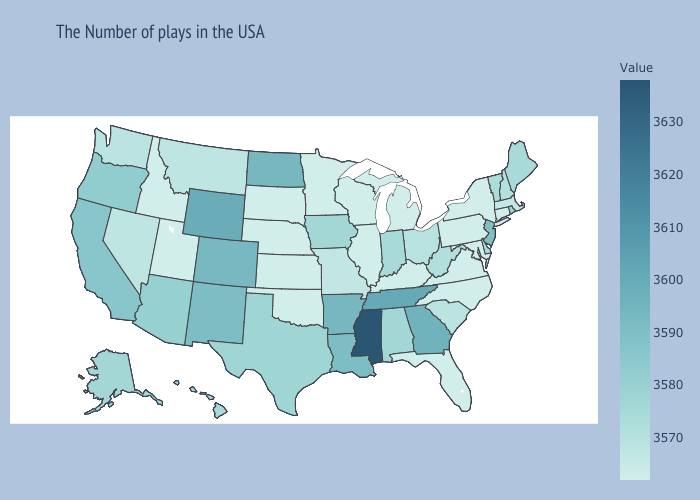Does Indiana have the highest value in the MidWest?
Keep it brief. No. Does Hawaii have the lowest value in the USA?
Quick response, please. No. Does Mississippi have the highest value in the USA?
Quick response, please. Yes. Is the legend a continuous bar?
Quick response, please. Yes. Among the states that border Utah , which have the lowest value?
Quick response, please. Idaho. Which states have the lowest value in the Northeast?
Give a very brief answer. Connecticut, New York, Pennsylvania. Does the map have missing data?
Keep it brief. No. 